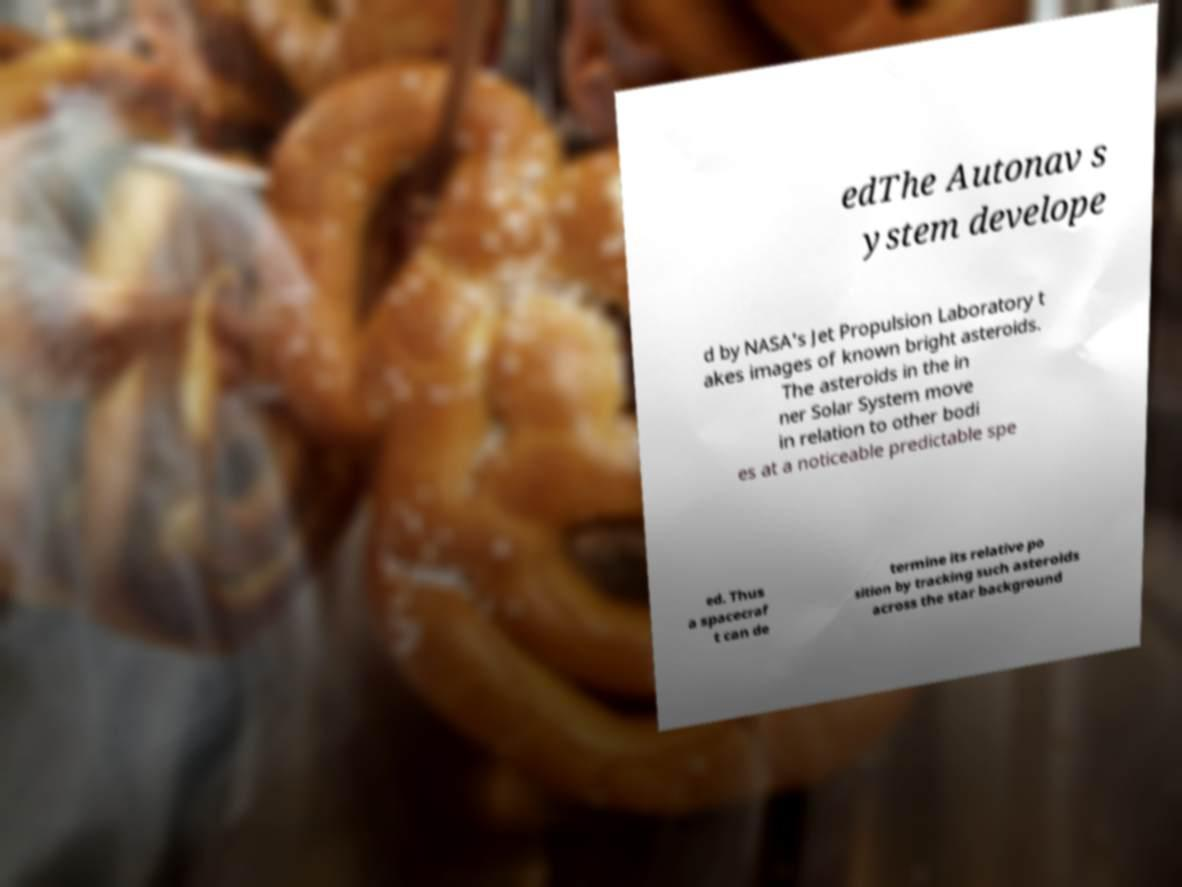What messages or text are displayed in this image? I need them in a readable, typed format. edThe Autonav s ystem develope d by NASA's Jet Propulsion Laboratory t akes images of known bright asteroids. The asteroids in the in ner Solar System move in relation to other bodi es at a noticeable predictable spe ed. Thus a spacecraf t can de termine its relative po sition by tracking such asteroids across the star background 